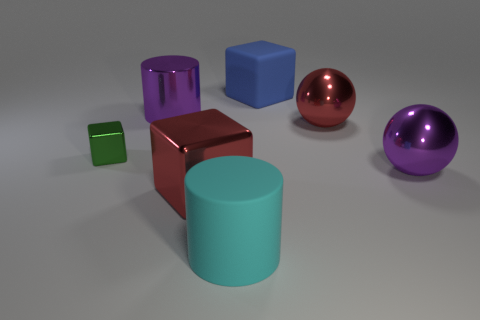Subtract all red metallic cubes. How many cubes are left? 2 Add 1 big cyan shiny objects. How many objects exist? 8 Subtract all green cubes. How many cubes are left? 2 Subtract all purple cubes. Subtract all cyan cylinders. How many cubes are left? 3 Subtract all red objects. Subtract all big red balls. How many objects are left? 4 Add 1 large shiny blocks. How many large shiny blocks are left? 2 Add 4 tiny blocks. How many tiny blocks exist? 5 Subtract 0 green balls. How many objects are left? 7 Subtract all cylinders. How many objects are left? 5 